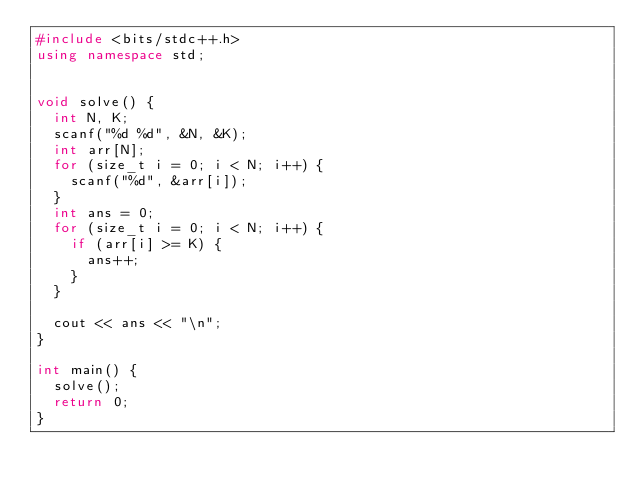Convert code to text. <code><loc_0><loc_0><loc_500><loc_500><_C++_>#include <bits/stdc++.h>
using namespace std;


void solve() {
  int N, K;
  scanf("%d %d", &N, &K);
  int arr[N];
  for (size_t i = 0; i < N; i++) {
    scanf("%d", &arr[i]);
  }
  int ans = 0;
  for (size_t i = 0; i < N; i++) {
    if (arr[i] >= K) {
      ans++;
    }
  }

  cout << ans << "\n";
}

int main() {
  solve();
  return 0;
}
</code> 